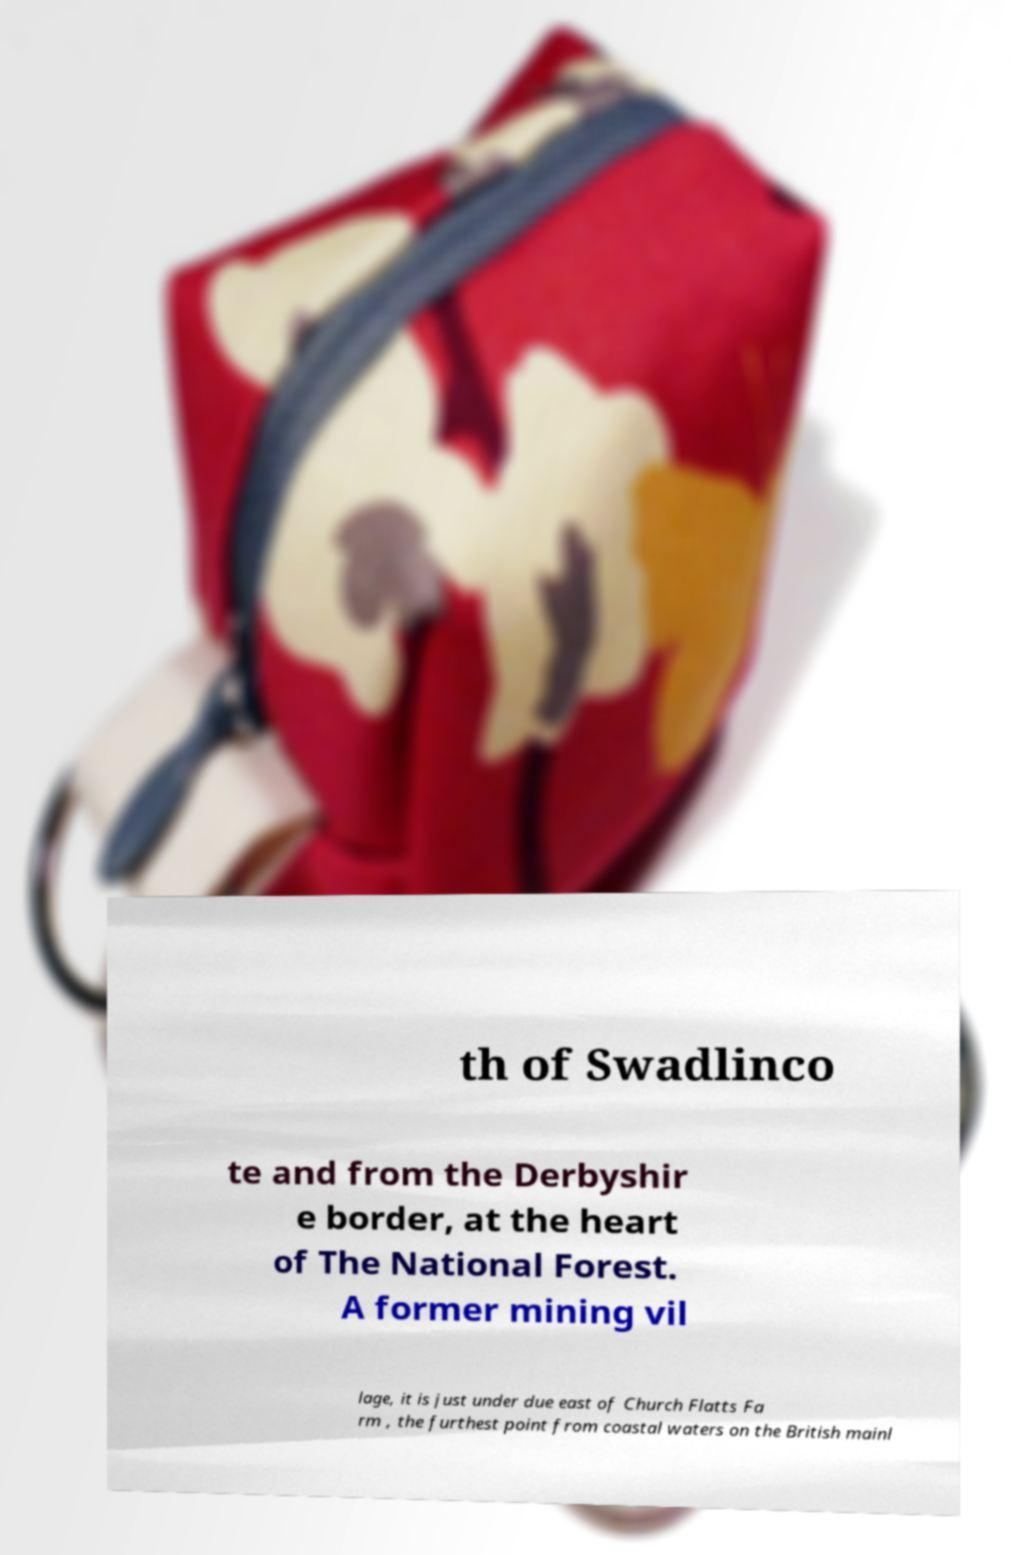Can you read and provide the text displayed in the image?This photo seems to have some interesting text. Can you extract and type it out for me? th of Swadlinco te and from the Derbyshir e border, at the heart of The National Forest. A former mining vil lage, it is just under due east of Church Flatts Fa rm , the furthest point from coastal waters on the British mainl 